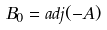Convert formula to latex. <formula><loc_0><loc_0><loc_500><loc_500>B _ { 0 } = a d j ( - A )</formula> 